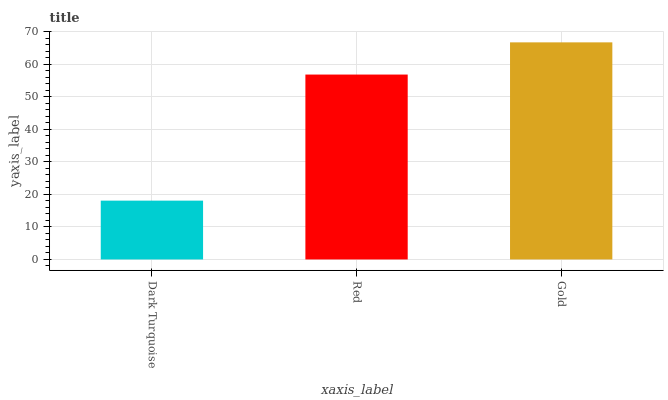Is Red the minimum?
Answer yes or no. No. Is Red the maximum?
Answer yes or no. No. Is Red greater than Dark Turquoise?
Answer yes or no. Yes. Is Dark Turquoise less than Red?
Answer yes or no. Yes. Is Dark Turquoise greater than Red?
Answer yes or no. No. Is Red less than Dark Turquoise?
Answer yes or no. No. Is Red the high median?
Answer yes or no. Yes. Is Red the low median?
Answer yes or no. Yes. Is Gold the high median?
Answer yes or no. No. Is Dark Turquoise the low median?
Answer yes or no. No. 